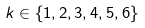Convert formula to latex. <formula><loc_0><loc_0><loc_500><loc_500>k \in \{ 1 , 2 , 3 , 4 , 5 , 6 \}</formula> 